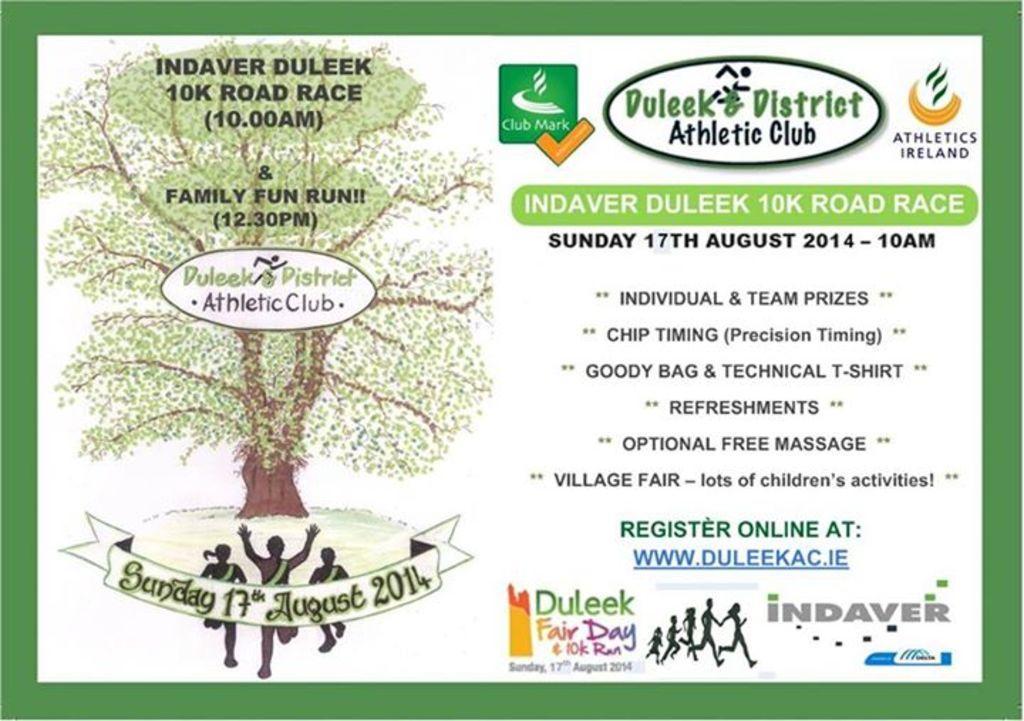Please provide a concise description of this image. In this image it looks like a poster in which there is a tree on the left side. On the right side there is some script. In front of the tree there are few runners running on the ground. It looks like a running race poster. 